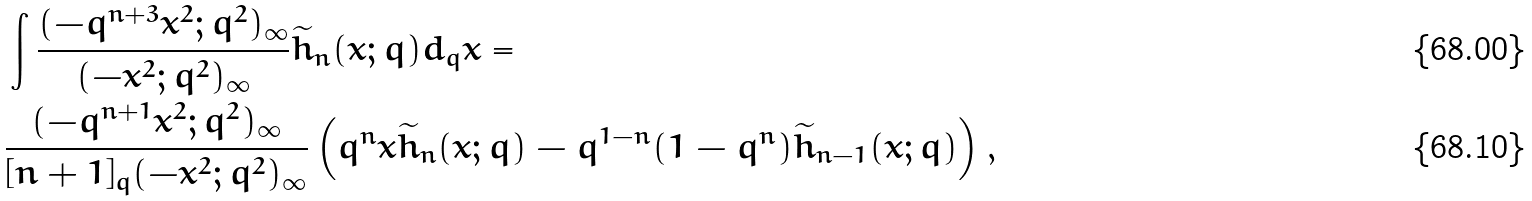Convert formula to latex. <formula><loc_0><loc_0><loc_500><loc_500>& \int \frac { ( - q ^ { n + 3 } x ^ { 2 } ; q ^ { 2 } ) _ { \infty } } { ( - x ^ { 2 } ; q ^ { 2 } ) _ { \infty } } \widetilde { h } _ { n } ( x ; q ) d _ { q } x = \\ & \frac { ( - q ^ { n + 1 } x ^ { 2 } ; q ^ { 2 } ) _ { \infty } } { [ n + 1 ] _ { q } ( - x ^ { 2 } ; q ^ { 2 } ) _ { \infty } } \left ( q ^ { n } x \widetilde { h } _ { n } ( x ; q ) - q ^ { 1 - n } ( 1 - q ^ { n } ) \widetilde { h } _ { n - 1 } ( x ; q ) \right ) ,</formula> 